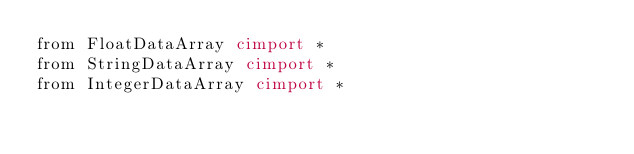Convert code to text. <code><loc_0><loc_0><loc_500><loc_500><_Cython_>from FloatDataArray cimport *
from StringDataArray cimport *
from IntegerDataArray cimport *

</code> 